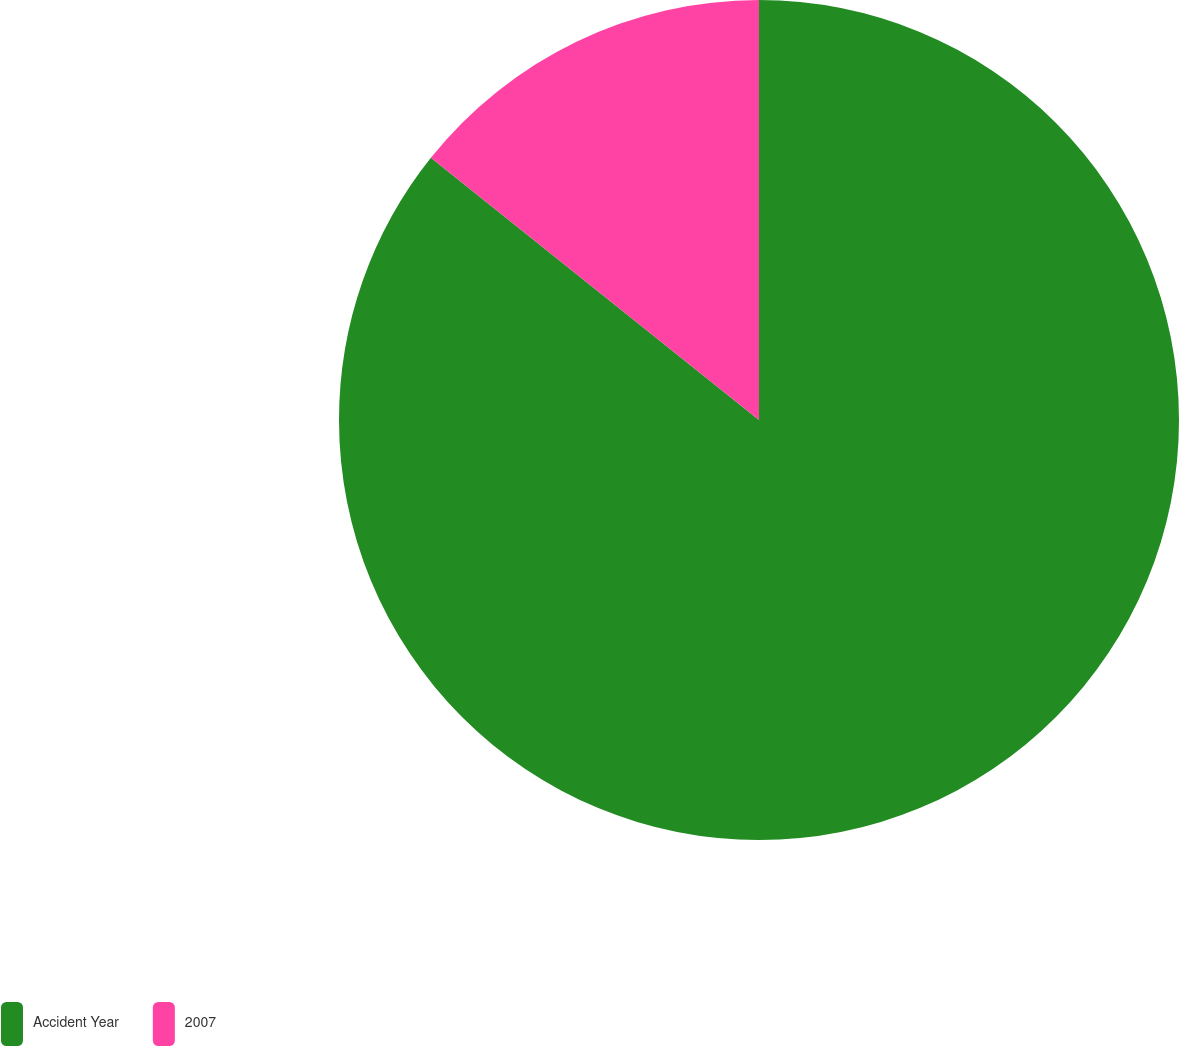Convert chart to OTSL. <chart><loc_0><loc_0><loc_500><loc_500><pie_chart><fcel>Accident Year<fcel>2007<nl><fcel>85.73%<fcel>14.27%<nl></chart> 